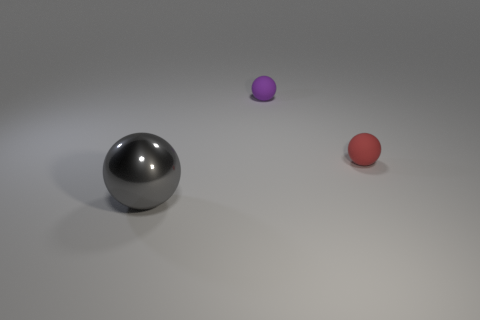How many other metal objects are the same size as the purple object?
Your response must be concise. 0. The ball that is behind the metallic ball and to the left of the red object is what color?
Your answer should be very brief. Purple. What number of things are either purple rubber balls or metallic balls?
Give a very brief answer. 2. How many big objects are either green rubber spheres or shiny things?
Make the answer very short. 1. Is there any other thing of the same color as the big sphere?
Give a very brief answer. No. What is the size of the sphere that is behind the large gray metallic object and left of the red matte object?
Make the answer very short. Small. There is a matte ball that is right of the tiny purple sphere; is its color the same as the sphere that is in front of the small red thing?
Make the answer very short. No. How many other objects are the same material as the red sphere?
Give a very brief answer. 1. What is the shape of the thing that is in front of the small purple ball and on the right side of the large sphere?
Provide a short and direct response. Sphere. Does the metal ball have the same color as the small matte thing that is in front of the purple matte sphere?
Your response must be concise. No. 